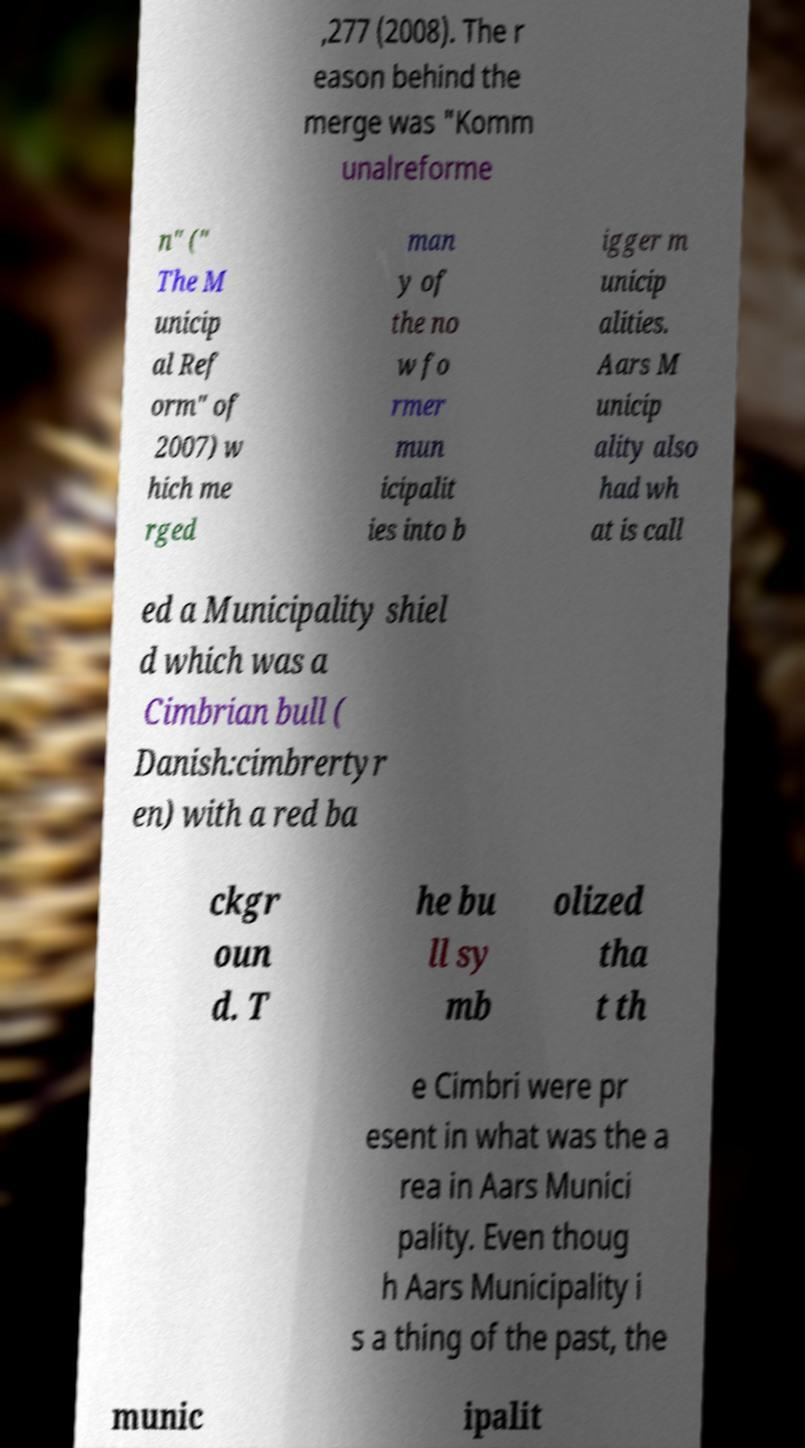I need the written content from this picture converted into text. Can you do that? ,277 (2008). The r eason behind the merge was "Komm unalreforme n" (" The M unicip al Ref orm" of 2007) w hich me rged man y of the no w fo rmer mun icipalit ies into b igger m unicip alities. Aars M unicip ality also had wh at is call ed a Municipality shiel d which was a Cimbrian bull ( Danish:cimbrertyr en) with a red ba ckgr oun d. T he bu ll sy mb olized tha t th e Cimbri were pr esent in what was the a rea in Aars Munici pality. Even thoug h Aars Municipality i s a thing of the past, the munic ipalit 